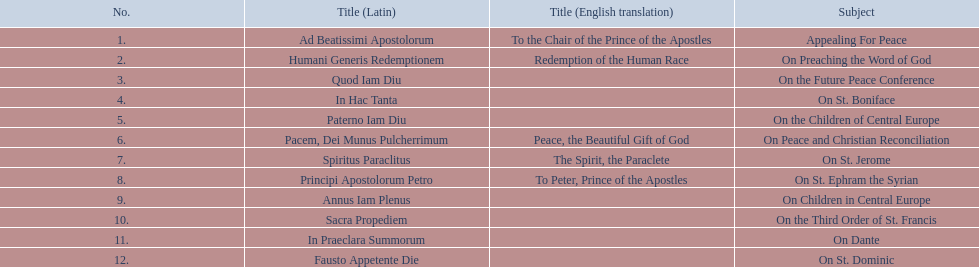What are all the subjects? Appealing For Peace, On Preaching the Word of God, On the Future Peace Conference, On St. Boniface, On the Children of Central Europe, On Peace and Christian Reconciliation, On St. Jerome, On St. Ephram the Syrian, On Children in Central Europe, On the Third Order of St. Francis, On Dante, On St. Dominic. Which occurred in 1920? On Peace and Christian Reconciliation, On St. Jerome, On St. Ephram the Syrian, On Children in Central Europe. Which occurred in may of that year? On Peace and Christian Reconciliation. 